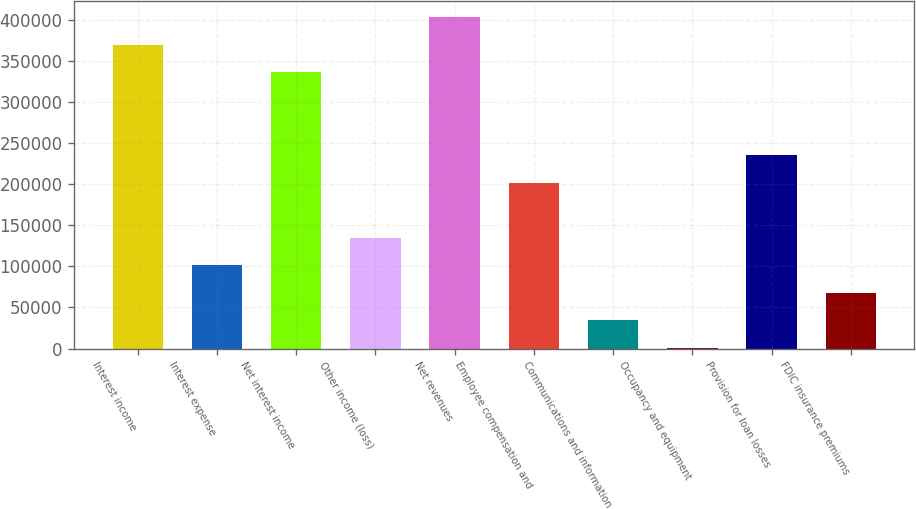<chart> <loc_0><loc_0><loc_500><loc_500><bar_chart><fcel>Interest income<fcel>Interest expense<fcel>Net interest income<fcel>Other income (loss)<fcel>Net revenues<fcel>Employee compensation and<fcel>Communications and information<fcel>Occupancy and equipment<fcel>Provision for loan losses<fcel>FDIC insurance premiums<nl><fcel>369546<fcel>101449<fcel>336034<fcel>134961<fcel>403058<fcel>201985<fcel>34424.2<fcel>912<fcel>235497<fcel>67936.4<nl></chart> 